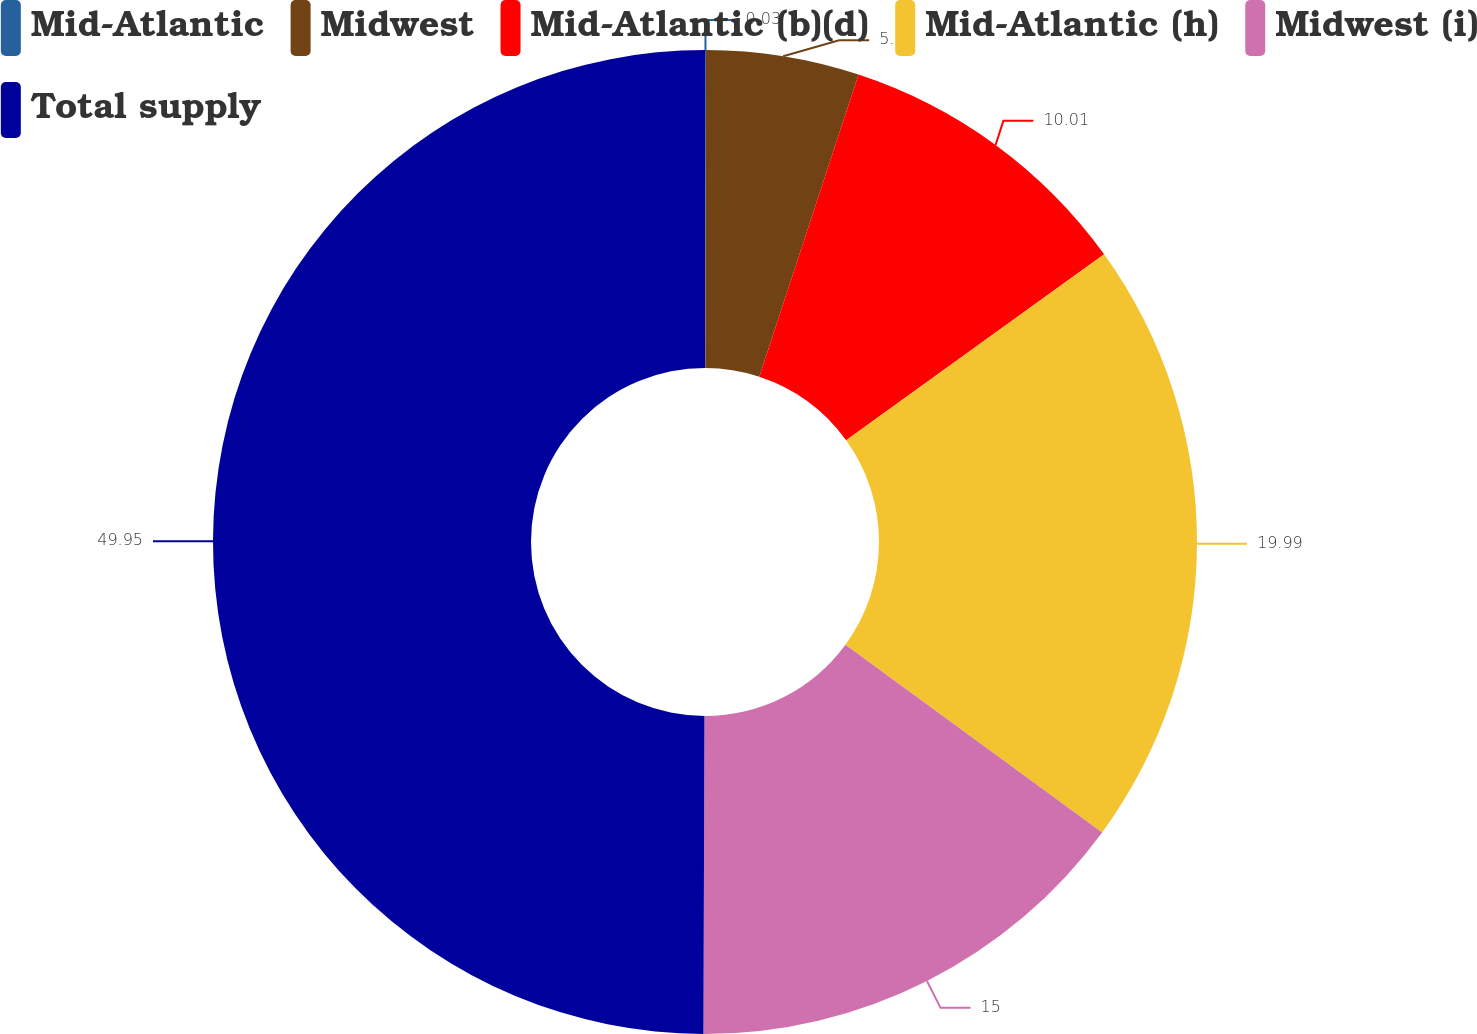Convert chart to OTSL. <chart><loc_0><loc_0><loc_500><loc_500><pie_chart><fcel>Mid-Atlantic<fcel>Midwest<fcel>Mid-Atlantic (b)(d)<fcel>Mid-Atlantic (h)<fcel>Midwest (i)<fcel>Total supply<nl><fcel>0.03%<fcel>5.02%<fcel>10.01%<fcel>19.99%<fcel>15.0%<fcel>49.95%<nl></chart> 